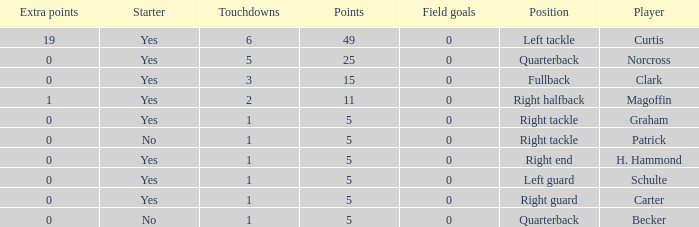Name the most touchdowns for becker  1.0. 